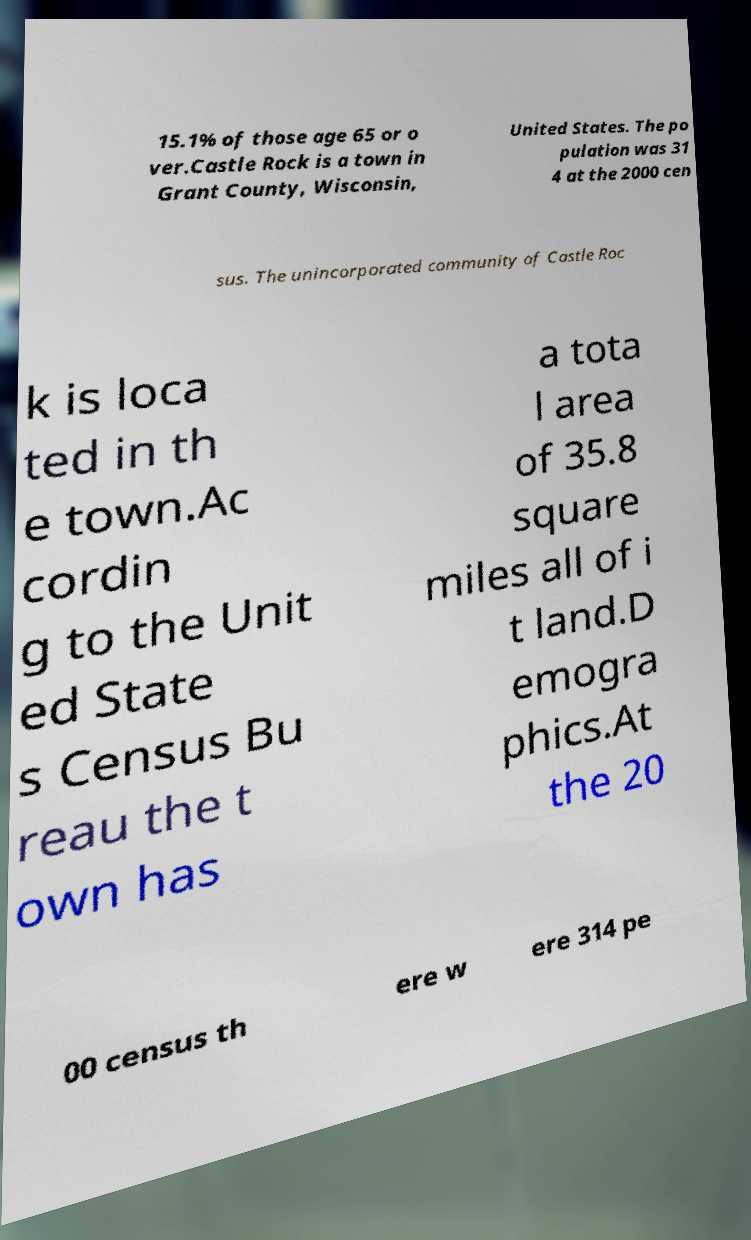Please identify and transcribe the text found in this image. 15.1% of those age 65 or o ver.Castle Rock is a town in Grant County, Wisconsin, United States. The po pulation was 31 4 at the 2000 cen sus. The unincorporated community of Castle Roc k is loca ted in th e town.Ac cordin g to the Unit ed State s Census Bu reau the t own has a tota l area of 35.8 square miles all of i t land.D emogra phics.At the 20 00 census th ere w ere 314 pe 